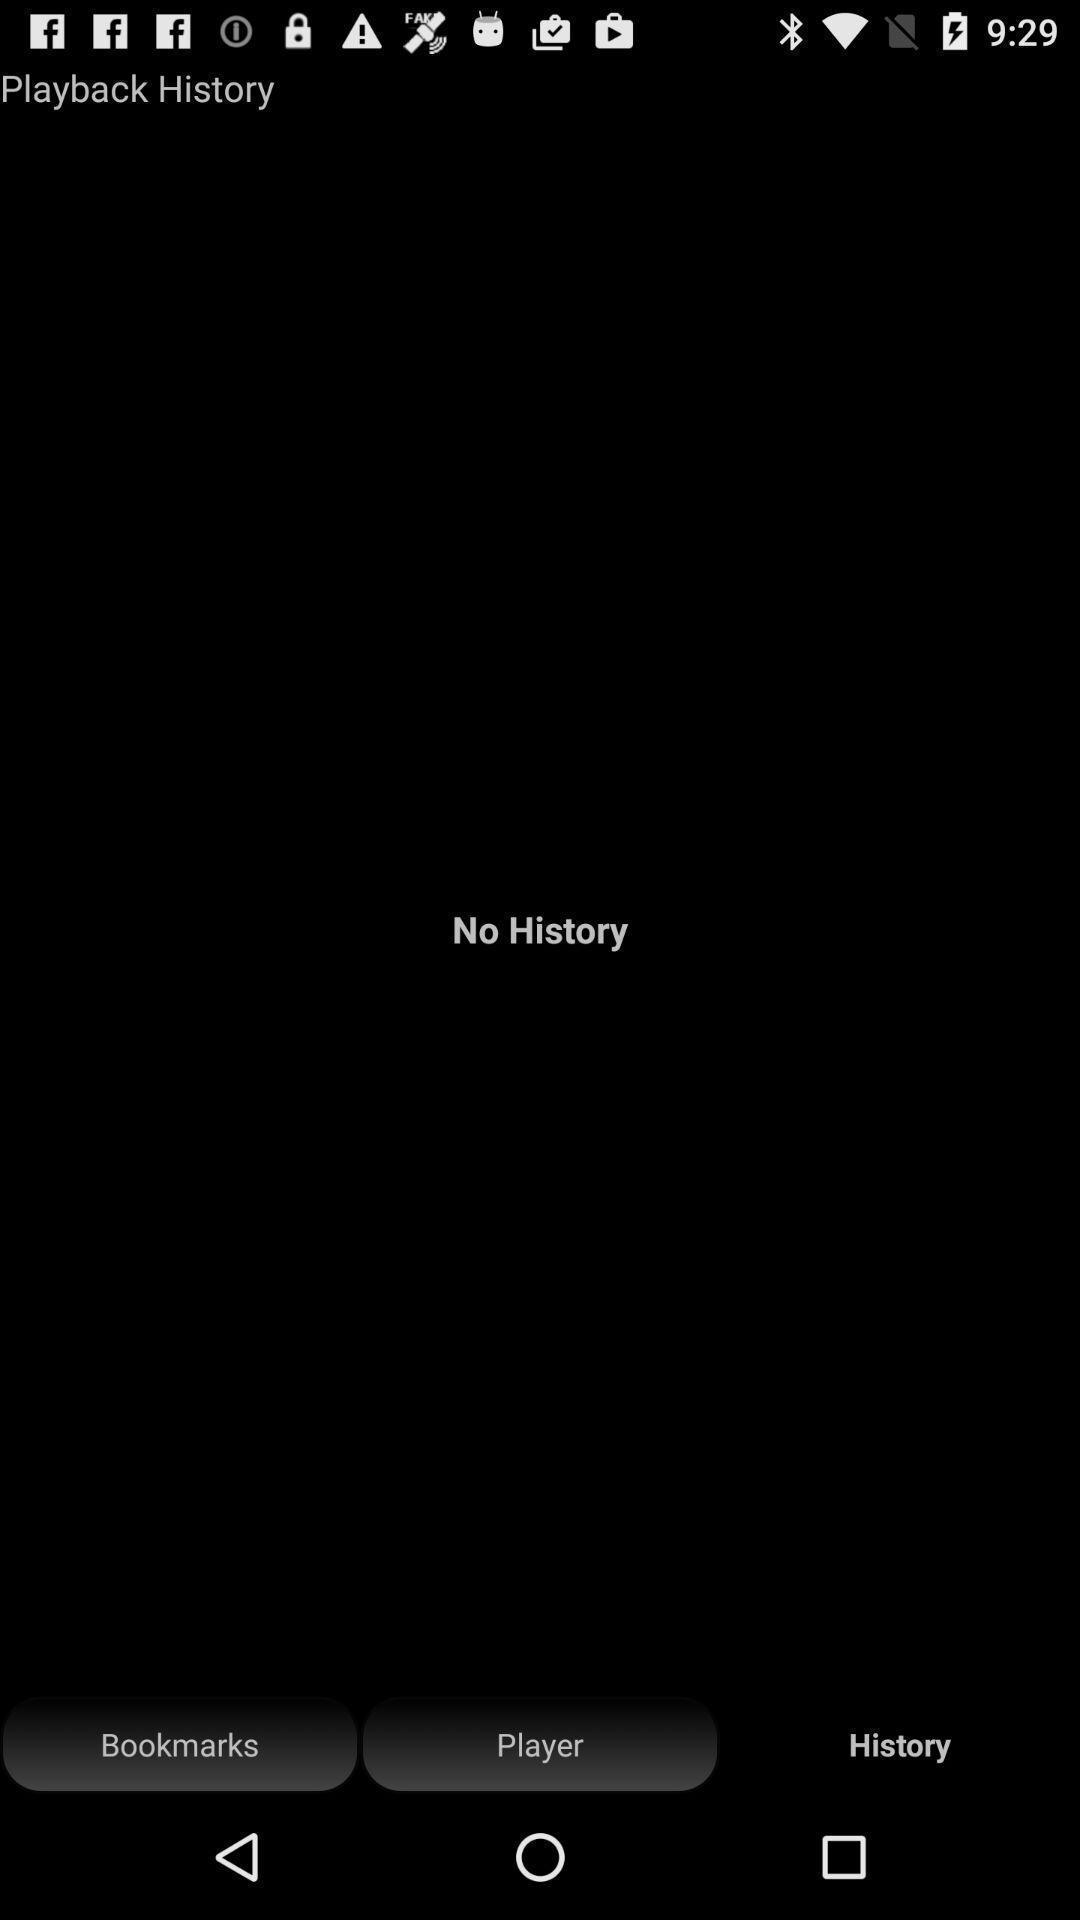Summarize the main components in this picture. Page is showing no history. 